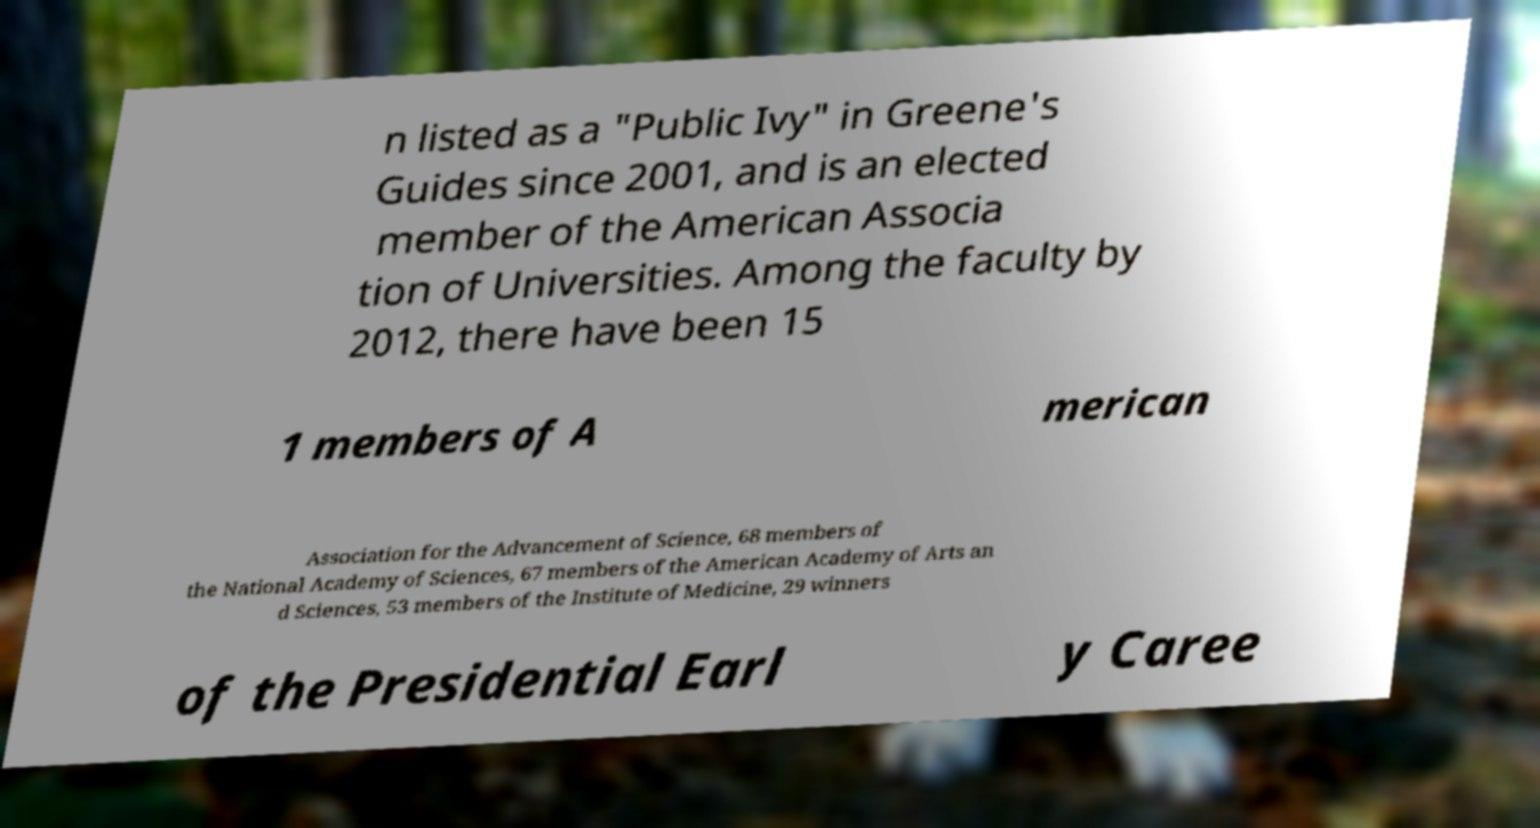Please identify and transcribe the text found in this image. n listed as a "Public Ivy" in Greene's Guides since 2001, and is an elected member of the American Associa tion of Universities. Among the faculty by 2012, there have been 15 1 members of A merican Association for the Advancement of Science, 68 members of the National Academy of Sciences, 67 members of the American Academy of Arts an d Sciences, 53 members of the Institute of Medicine, 29 winners of the Presidential Earl y Caree 